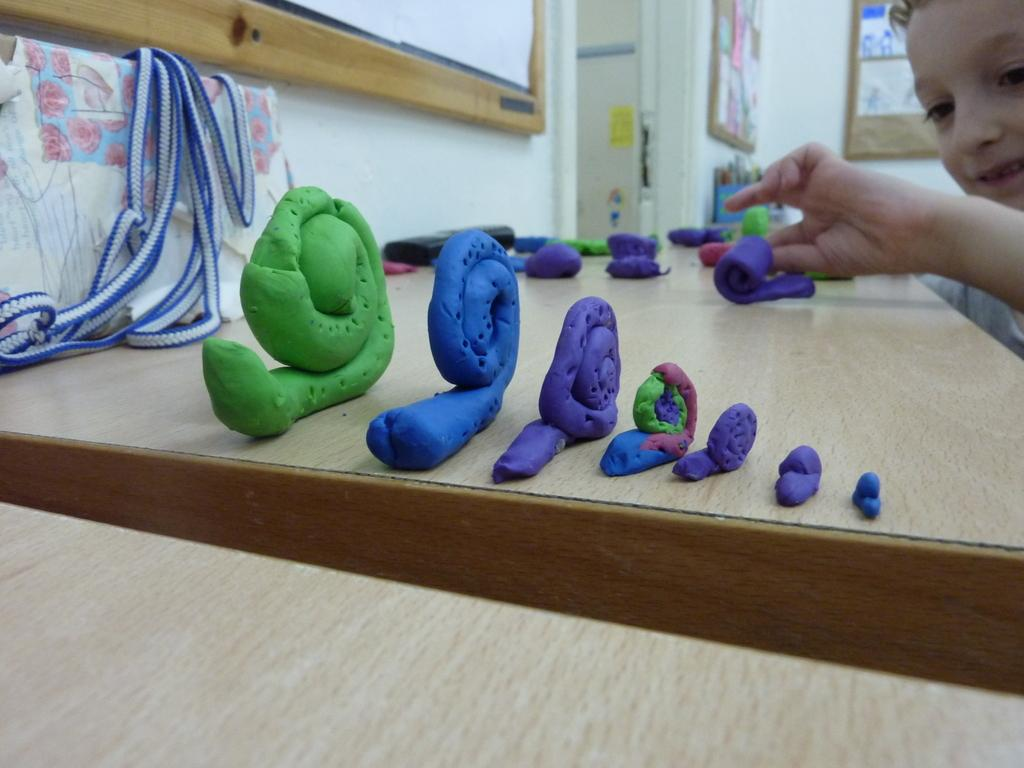What type of objects are on the wooden surface in the image? There are clay objects on a wooden surface in the image. Can you describe the person in the image? There is a person in the image, but no specific details about their appearance or actions are provided. What is on the wall in the image? There is a wall with a board and some posters in the image. What can be seen on the left side of the image? There is an object on the left side of the image, but no specific details about the object are provided. What type of van is parked outside the room in the image? There is no van present in the image; it only shows clay objects on a wooden surface, a person, a wall with a board and posters, and an object on the left side. Who is the creator of the clay objects in the image? The identity of the creator of the clay objects is not mentioned in the image or the provided facts. 